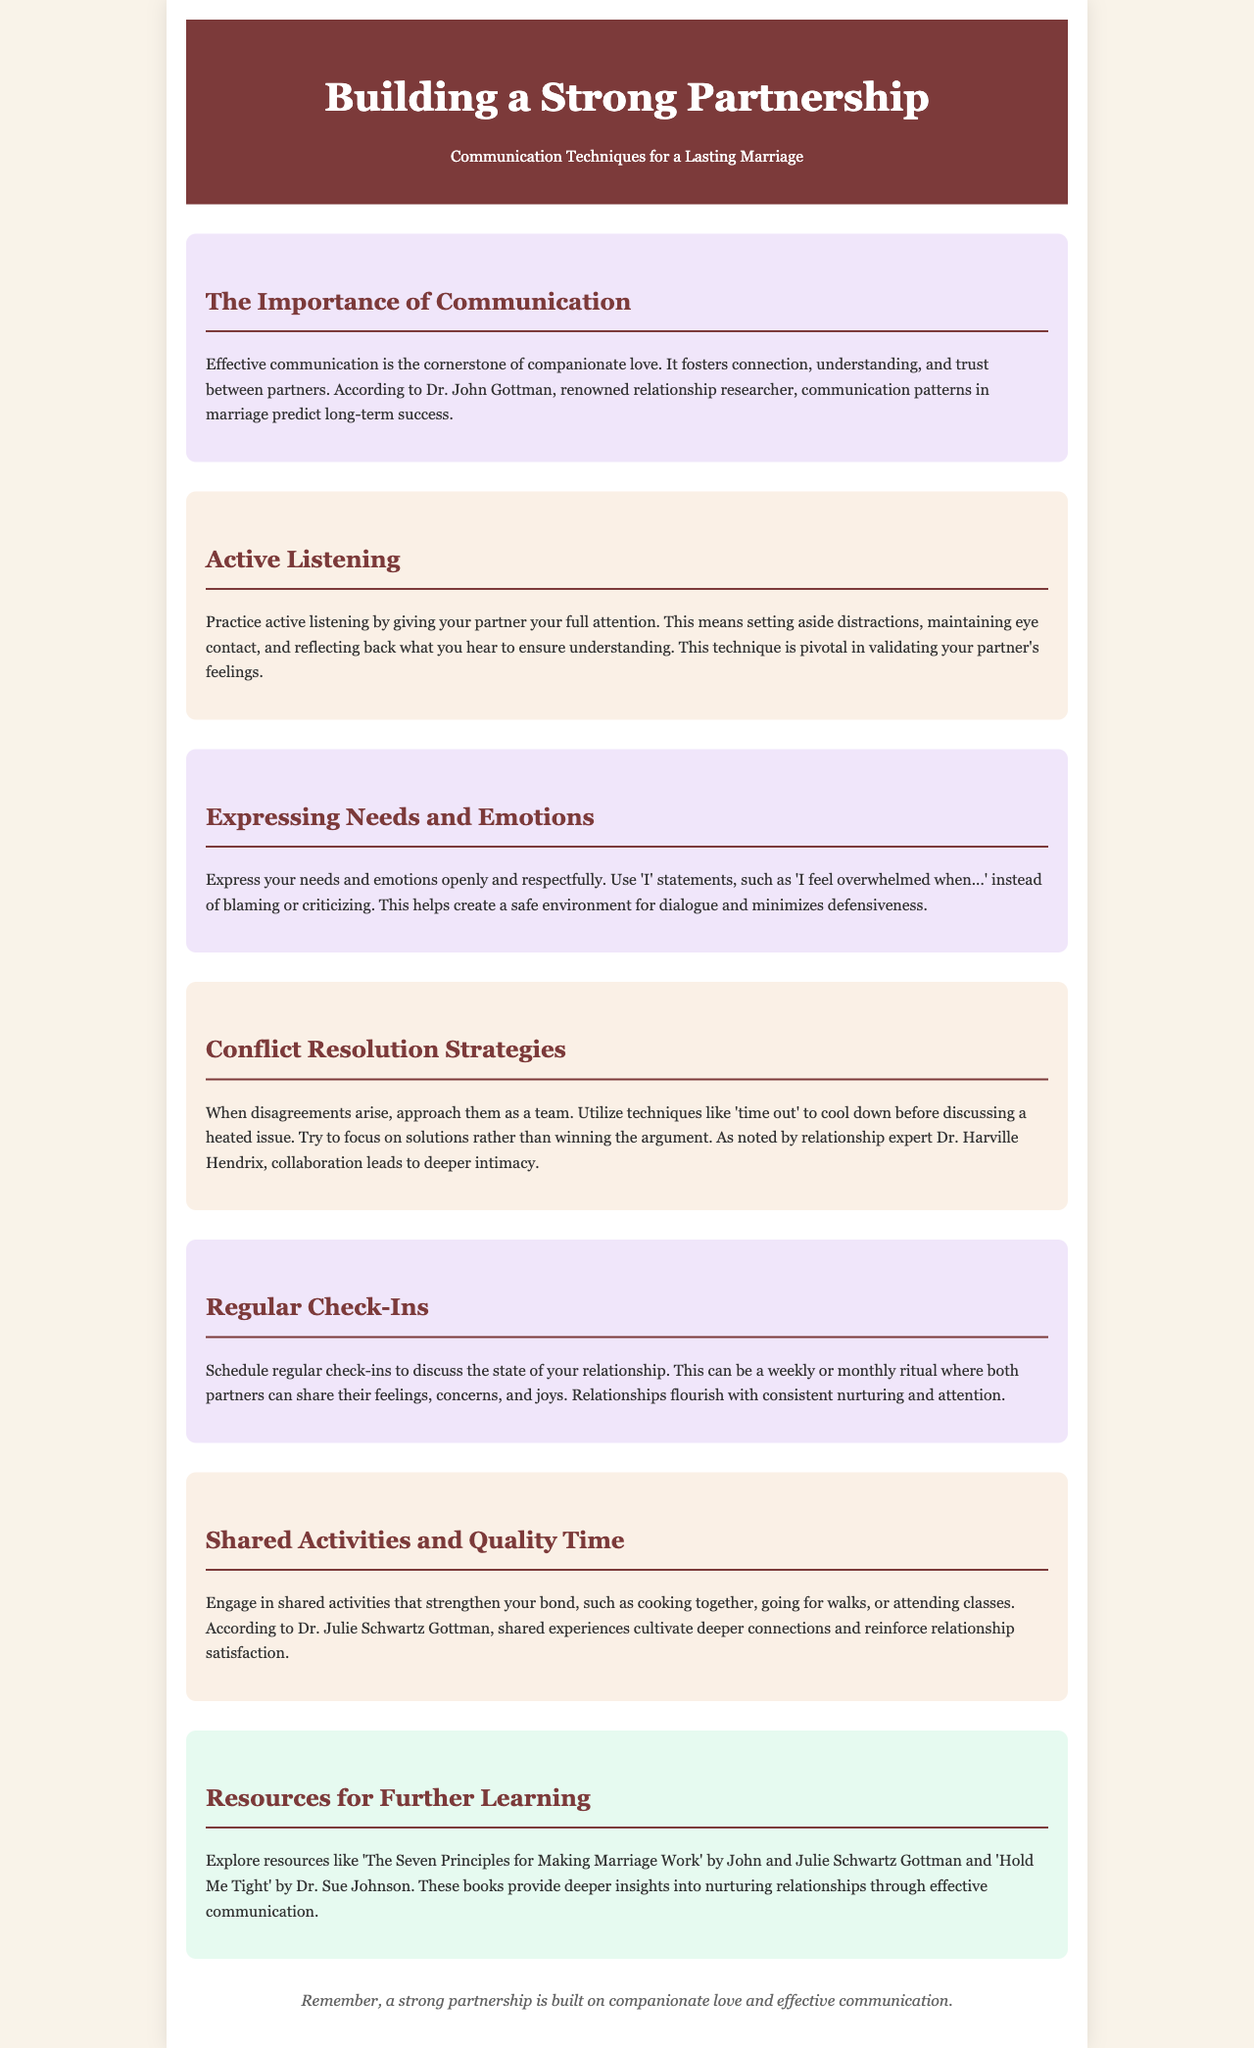What is the title of the brochure? The title of the brochure is presented in the header section, which introduces the main topic of the document.
Answer: Building a Strong Partnership What communication technique is highlighted as pivotal in validating feelings? The active listening section specifies the importance of this technique in relationships through effective communication.
Answer: Active Listening Who is the renowned relationship researcher mentioned in the document? The document cites Dr. John Gottman as a prominent figure known for his research on relationships and communication.
Answer: Dr. John Gottman What should couples use to express their feelings instead of blaming? The section on expressing needs and emotions encourages the use of a specific type of statement to enhance communication.
Answer: 'I' statements What does regular check-ins help couples to discuss? The document outlines a specific activity aimed at fostering understanding and attention in a marriage relationship.
Answer: Feelings, concerns, and joys Which expert is noted for the importance of collaboration in conflict resolution? The conflict resolution strategies section references a particular expert whose insights are valuable for overcoming disagreements.
Answer: Dr. Harville Hendrix What kind of activities should couples engage in to strengthen their bond? The shared activities section suggests various examples of interactions that enhance relationship satisfaction.
Answer: Shared activities What is a recommended resource for learning about nurturing relationships? The resources section provides titles of books that offer deeper insights on effective communication in marriages.
Answer: 'The Seven Principles for Making Marriage Work' What is emphasized as the cornerstone of companionate love? The importance of communication section identifies a key element that significantly impacts relationships.
Answer: Effective communication 